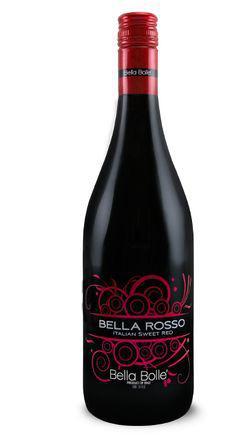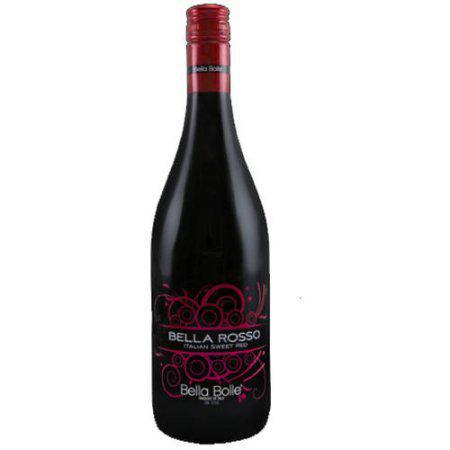The first image is the image on the left, the second image is the image on the right. Examine the images to the left and right. Is the description "All bottles are dark with red trim and withthe same long-necked shape." accurate? Answer yes or no. Yes. 